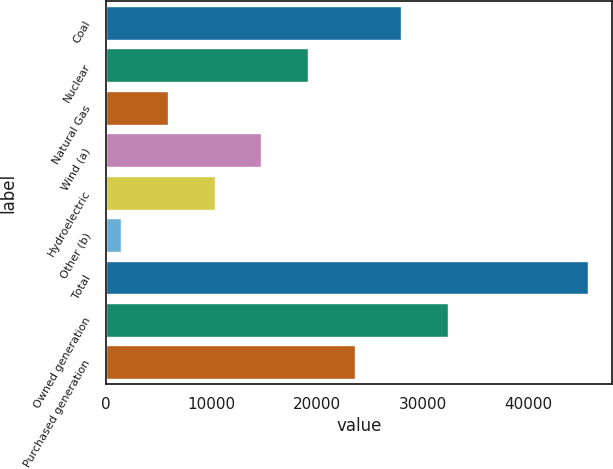<chart> <loc_0><loc_0><loc_500><loc_500><bar_chart><fcel>Coal<fcel>Nuclear<fcel>Natural Gas<fcel>Wind (a)<fcel>Hydroelectric<fcel>Other (b)<fcel>Total<fcel>Owned generation<fcel>Purchased generation<nl><fcel>27994<fcel>19147<fcel>5876.5<fcel>14723.5<fcel>10300<fcel>1453<fcel>45688<fcel>32417.5<fcel>23570.5<nl></chart> 